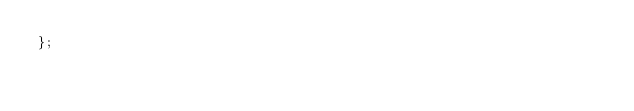Convert code to text. <code><loc_0><loc_0><loc_500><loc_500><_JavaScript_>};</code> 